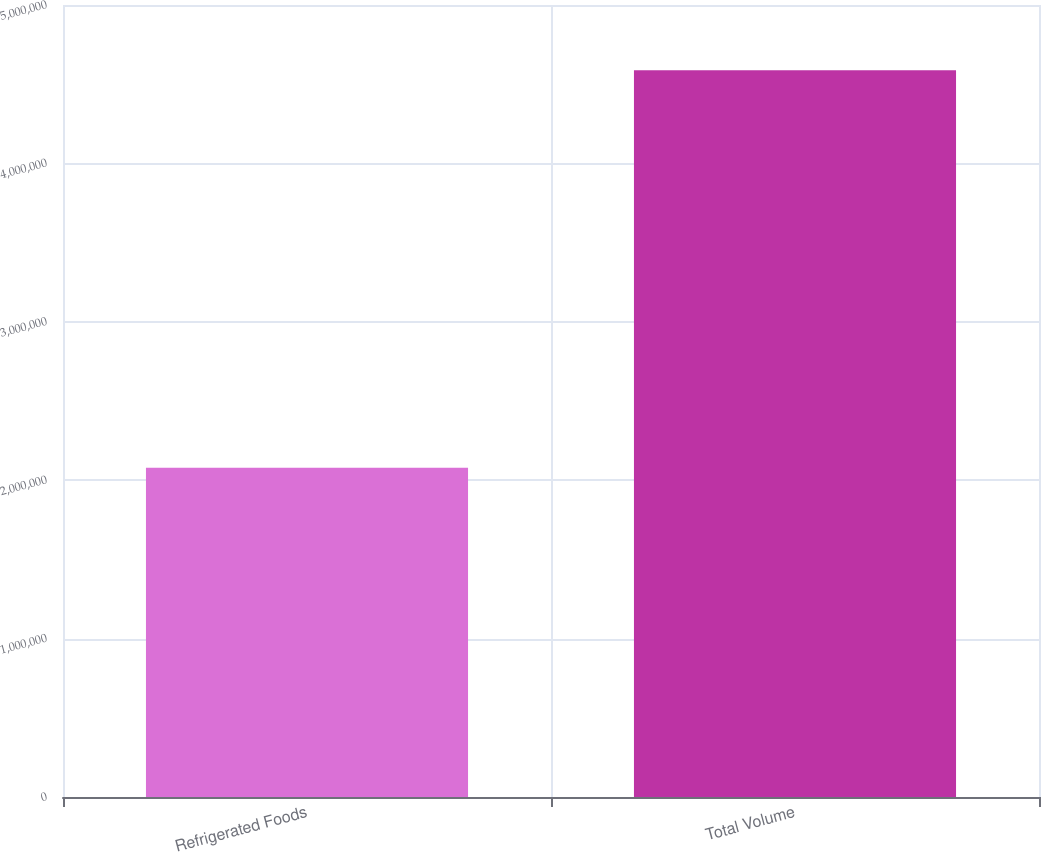Convert chart. <chart><loc_0><loc_0><loc_500><loc_500><bar_chart><fcel>Refrigerated Foods<fcel>Total Volume<nl><fcel>2.07811e+06<fcel>4.58858e+06<nl></chart> 